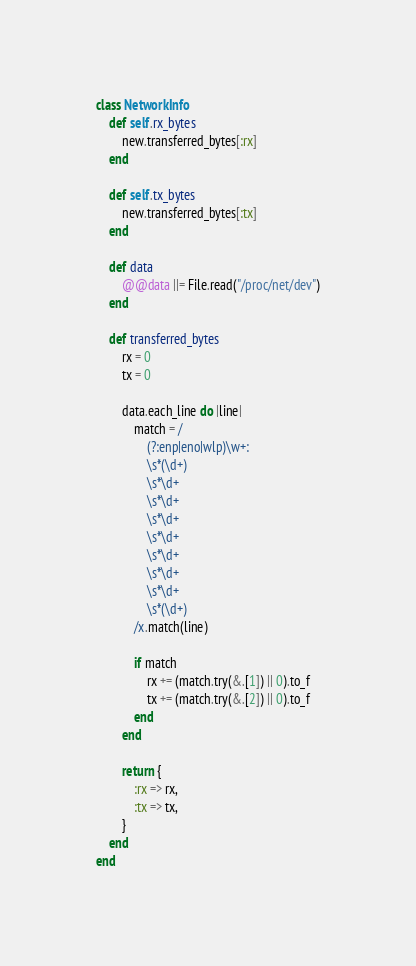Convert code to text. <code><loc_0><loc_0><loc_500><loc_500><_Crystal_>class NetworkInfo
    def self.rx_bytes
        new.transferred_bytes[:rx]
    end

    def self.tx_bytes
        new.transferred_bytes[:tx]
    end

    def data
        @@data ||= File.read("/proc/net/dev")
    end

    def transferred_bytes
        rx = 0
        tx = 0

        data.each_line do |line|
            match = /
                (?:enp|eno|wlp)\w+:
                \s*(\d+)
                \s*\d+
                \s*\d+
                \s*\d+
                \s*\d+
                \s*\d+
                \s*\d+
                \s*\d+
                \s*(\d+)
            /x.match(line)

            if match
                rx += (match.try(&.[1]) || 0).to_f
                tx += (match.try(&.[2]) || 0).to_f
            end
        end

        return {
            :rx => rx,
            :tx => tx,
        }
    end
end
</code> 